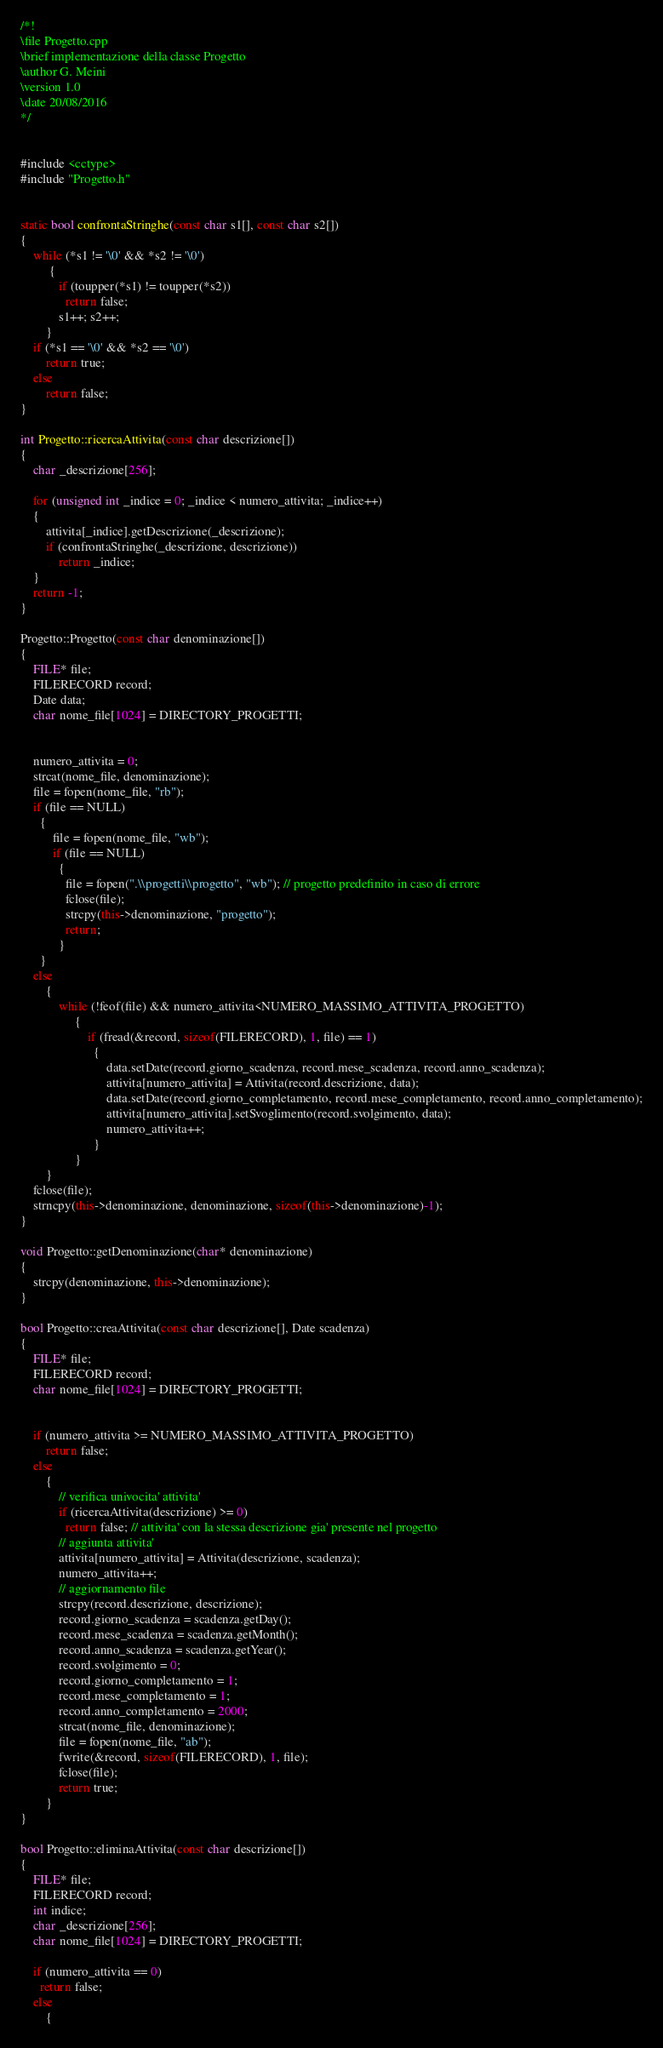Convert code to text. <code><loc_0><loc_0><loc_500><loc_500><_C++_>/*!
\file Progetto.cpp
\brief implementazione della classe Progetto
\author G. Meini
\version 1.0
\date 20/08/2016
*/


#include <cctype>
#include "Progetto.h"


static bool confrontaStringhe(const char s1[], const char s2[])
{
	while (*s1 != '\0' && *s2 != '\0')
	     {
			if (toupper(*s1) != toupper(*s2))
			  return false;
			s1++; s2++;
	    }
	if (*s1 == '\0' && *s2 == '\0')
		return true;
	else
		return false;
}

int Progetto::ricercaAttivita(const char descrizione[])
{
	char _descrizione[256];

	for (unsigned int _indice = 0; _indice < numero_attivita; _indice++)
	{
		attivita[_indice].getDescrizione(_descrizione);
		if (confrontaStringhe(_descrizione, descrizione))
			return _indice;
	}
	return -1;
}

Progetto::Progetto(const char denominazione[])
{
	FILE* file;
	FILERECORD record;
	Date data;
	char nome_file[1024] = DIRECTORY_PROGETTI;


	numero_attivita = 0;
	strcat(nome_file, denominazione);
	file = fopen(nome_file, "rb");
	if (file == NULL)
	  {
		  file = fopen(nome_file, "wb");
		  if (file == NULL)
		    {
			  file = fopen(".\\progetti\\progetto", "wb"); // progetto predefinito in caso di errore
			  fclose(file);
			  strcpy(this->denominazione, "progetto");
			  return;
		    }
	  }
	else
	    {
			while (!feof(file) && numero_attivita<NUMERO_MASSIMO_ATTIVITA_PROGETTO)
			     {
					 if (fread(&record, sizeof(FILERECORD), 1, file) == 1)
					   {
						   data.setDate(record.giorno_scadenza, record.mese_scadenza, record.anno_scadenza);
						   attivita[numero_attivita] = Attivita(record.descrizione, data);
						   data.setDate(record.giorno_completamento, record.mese_completamento, record.anno_completamento);
						   attivita[numero_attivita].setSvoglimento(record.svolgimento, data);
						   numero_attivita++;
					   }
			     }
	    }
	fclose(file);
	strncpy(this->denominazione, denominazione, sizeof(this->denominazione)-1);
}

void Progetto::getDenominazione(char* denominazione)
{
	strcpy(denominazione, this->denominazione);
}

bool Progetto::creaAttivita(const char descrizione[], Date scadenza)
{
	FILE* file;
	FILERECORD record;
	char nome_file[1024] = DIRECTORY_PROGETTI;


	if (numero_attivita >= NUMERO_MASSIMO_ATTIVITA_PROGETTO)
		return false;
	else
	    {
			// verifica univocita' attivita'
			if (ricercaAttivita(descrizione) >= 0)
              return false; // attivita' con la stessa descrizione gia' presente nel progetto
			// aggiunta attivita'
			attivita[numero_attivita] = Attivita(descrizione, scadenza);
			numero_attivita++;
			// aggiornamento file
			strcpy(record.descrizione, descrizione);
			record.giorno_scadenza = scadenza.getDay();
			record.mese_scadenza = scadenza.getMonth();
			record.anno_scadenza = scadenza.getYear();
			record.svolgimento = 0;
			record.giorno_completamento = 1;
			record.mese_completamento = 1;
			record.anno_completamento = 2000;
			strcat(nome_file, denominazione);
			file = fopen(nome_file, "ab");
			fwrite(&record, sizeof(FILERECORD), 1, file);
			fclose(file);
			return true;
	    }
}

bool Progetto::eliminaAttivita(const char descrizione[])
{
	FILE* file;
	FILERECORD record;
	int indice;
	char _descrizione[256];
	char nome_file[1024] = DIRECTORY_PROGETTI;

	if (numero_attivita == 0)
	  return false;
	else
	    {</code> 